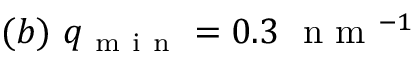Convert formula to latex. <formula><loc_0><loc_0><loc_500><loc_500>( b ) \ q _ { m i n } = 0 . 3 \ n m ^ { - 1 }</formula> 